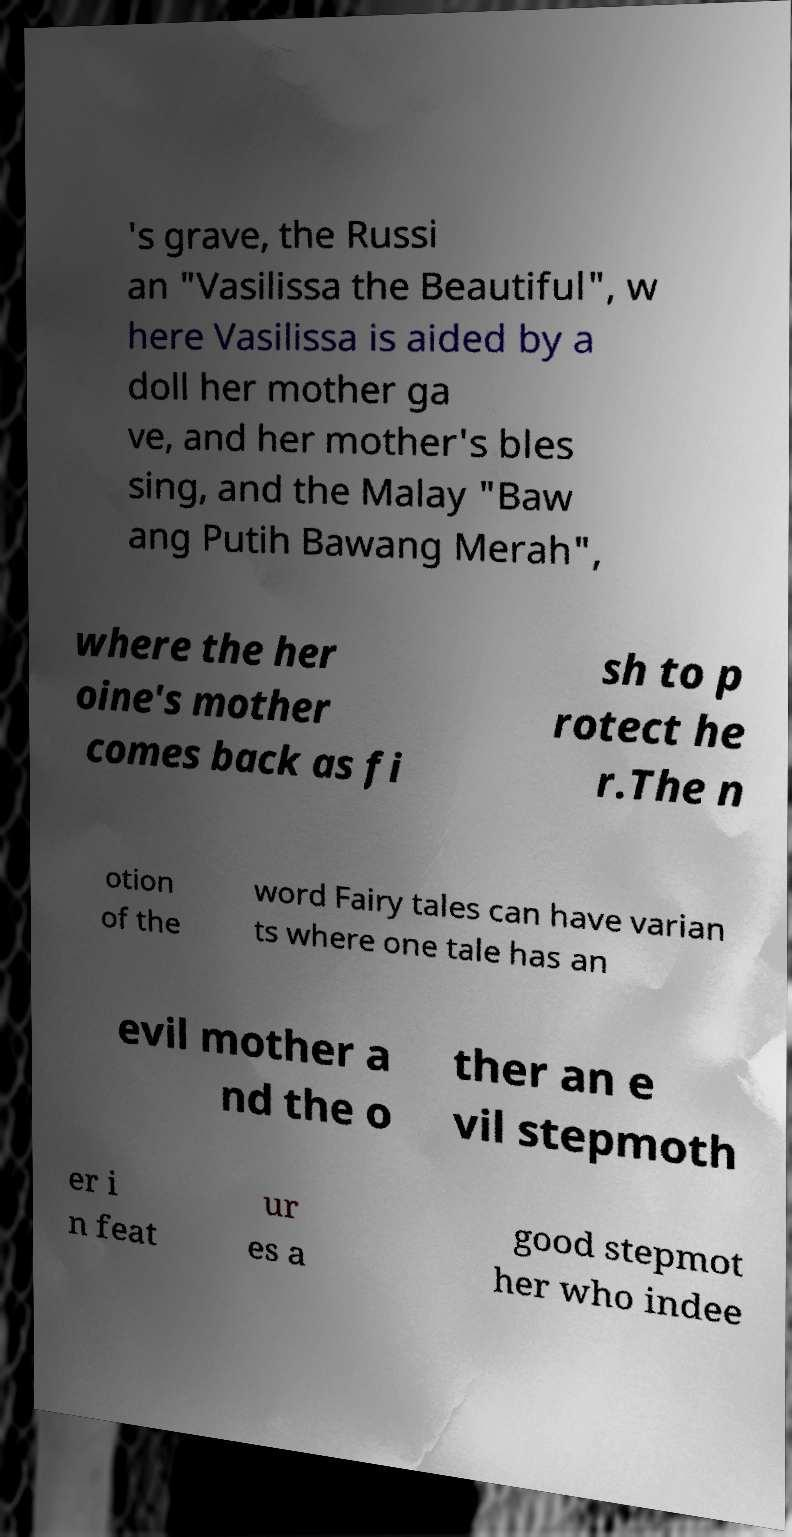Please read and relay the text visible in this image. What does it say? 's grave, the Russi an "Vasilissa the Beautiful", w here Vasilissa is aided by a doll her mother ga ve, and her mother's bles sing, and the Malay "Baw ang Putih Bawang Merah", where the her oine's mother comes back as fi sh to p rotect he r.The n otion of the word Fairy tales can have varian ts where one tale has an evil mother a nd the o ther an e vil stepmoth er i n feat ur es a good stepmot her who indee 